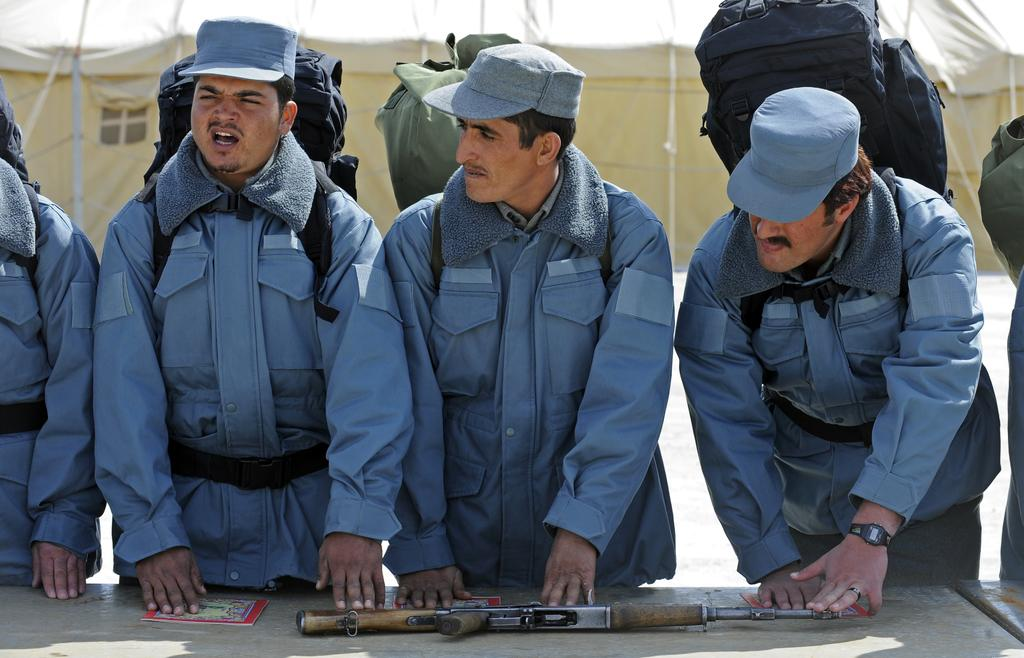How many people are in the image? There is a group of people in the image. What are the people wearing on their backs? The people are wearing backpacks. Where are the people standing in relation to the table? The people are standing in front of a table. What items can be seen on the table? There is a book and a gun on the table. What is visible in the background of the image? There is a tent visible in the background. What type of cup is being used to hold the authority in the image? There is no cup or authority present in the image. What type of farm animals can be seen in the image? There are no farm animals present in the image. 